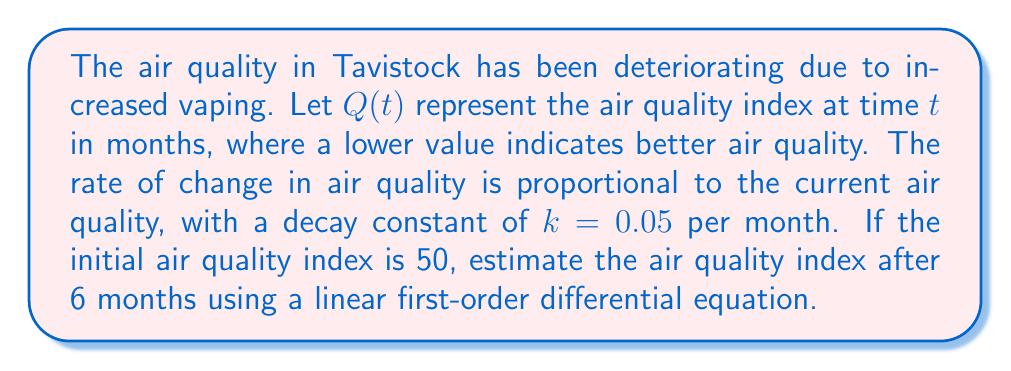Give your solution to this math problem. Let's approach this problem step-by-step:

1) The given information can be modeled using the following linear first-order differential equation:

   $$\frac{dQ}{dt} = kQ$$

   where $k = 0.05$ is the decay constant.

2) The general solution to this differential equation is:

   $$Q(t) = Q_0e^{kt}$$

   where $Q_0$ is the initial air quality index.

3) We're given the following initial condition:
   $Q_0 = 50$ at $t = 0$

4) Substituting the values into the general solution:

   $$Q(t) = 50e^{0.05t}$$

5) To find the air quality index after 6 months, we substitute $t = 6$:

   $$Q(6) = 50e^{0.05(6)}$$

6) Calculating this value:
   
   $$Q(6) = 50e^{0.3} \approx 50(1.3498588) \approx 67.49$$

7) Rounding to two decimal places:

   $$Q(6) \approx 67.49$$
Answer: The estimated air quality index after 6 months is approximately 67.49. 